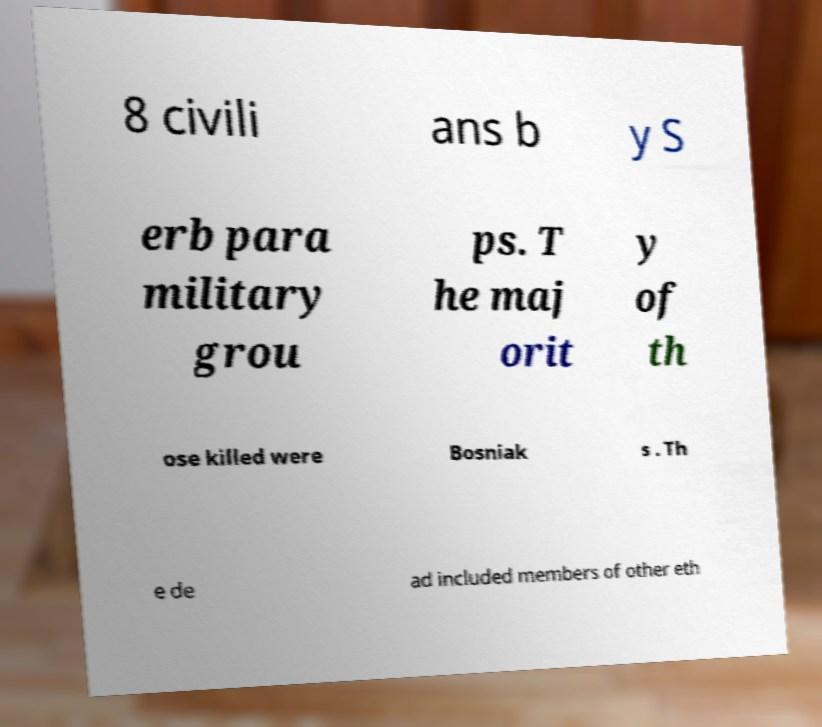What messages or text are displayed in this image? I need them in a readable, typed format. 8 civili ans b y S erb para military grou ps. T he maj orit y of th ose killed were Bosniak s . Th e de ad included members of other eth 